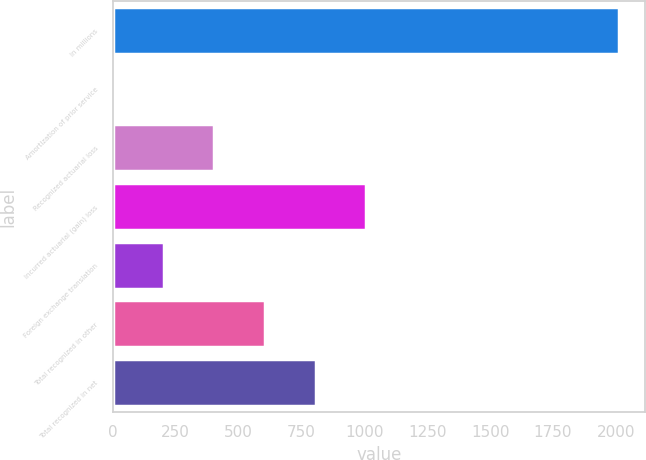Convert chart to OTSL. <chart><loc_0><loc_0><loc_500><loc_500><bar_chart><fcel>In millions<fcel>Amortization of prior service<fcel>Recognized actuarial loss<fcel>Incurred actuarial (gain) loss<fcel>Foreign exchange translation<fcel>Total recognized in other<fcel>Total recognized in net<nl><fcel>2014<fcel>1<fcel>403.6<fcel>1007.5<fcel>202.3<fcel>604.9<fcel>806.2<nl></chart> 